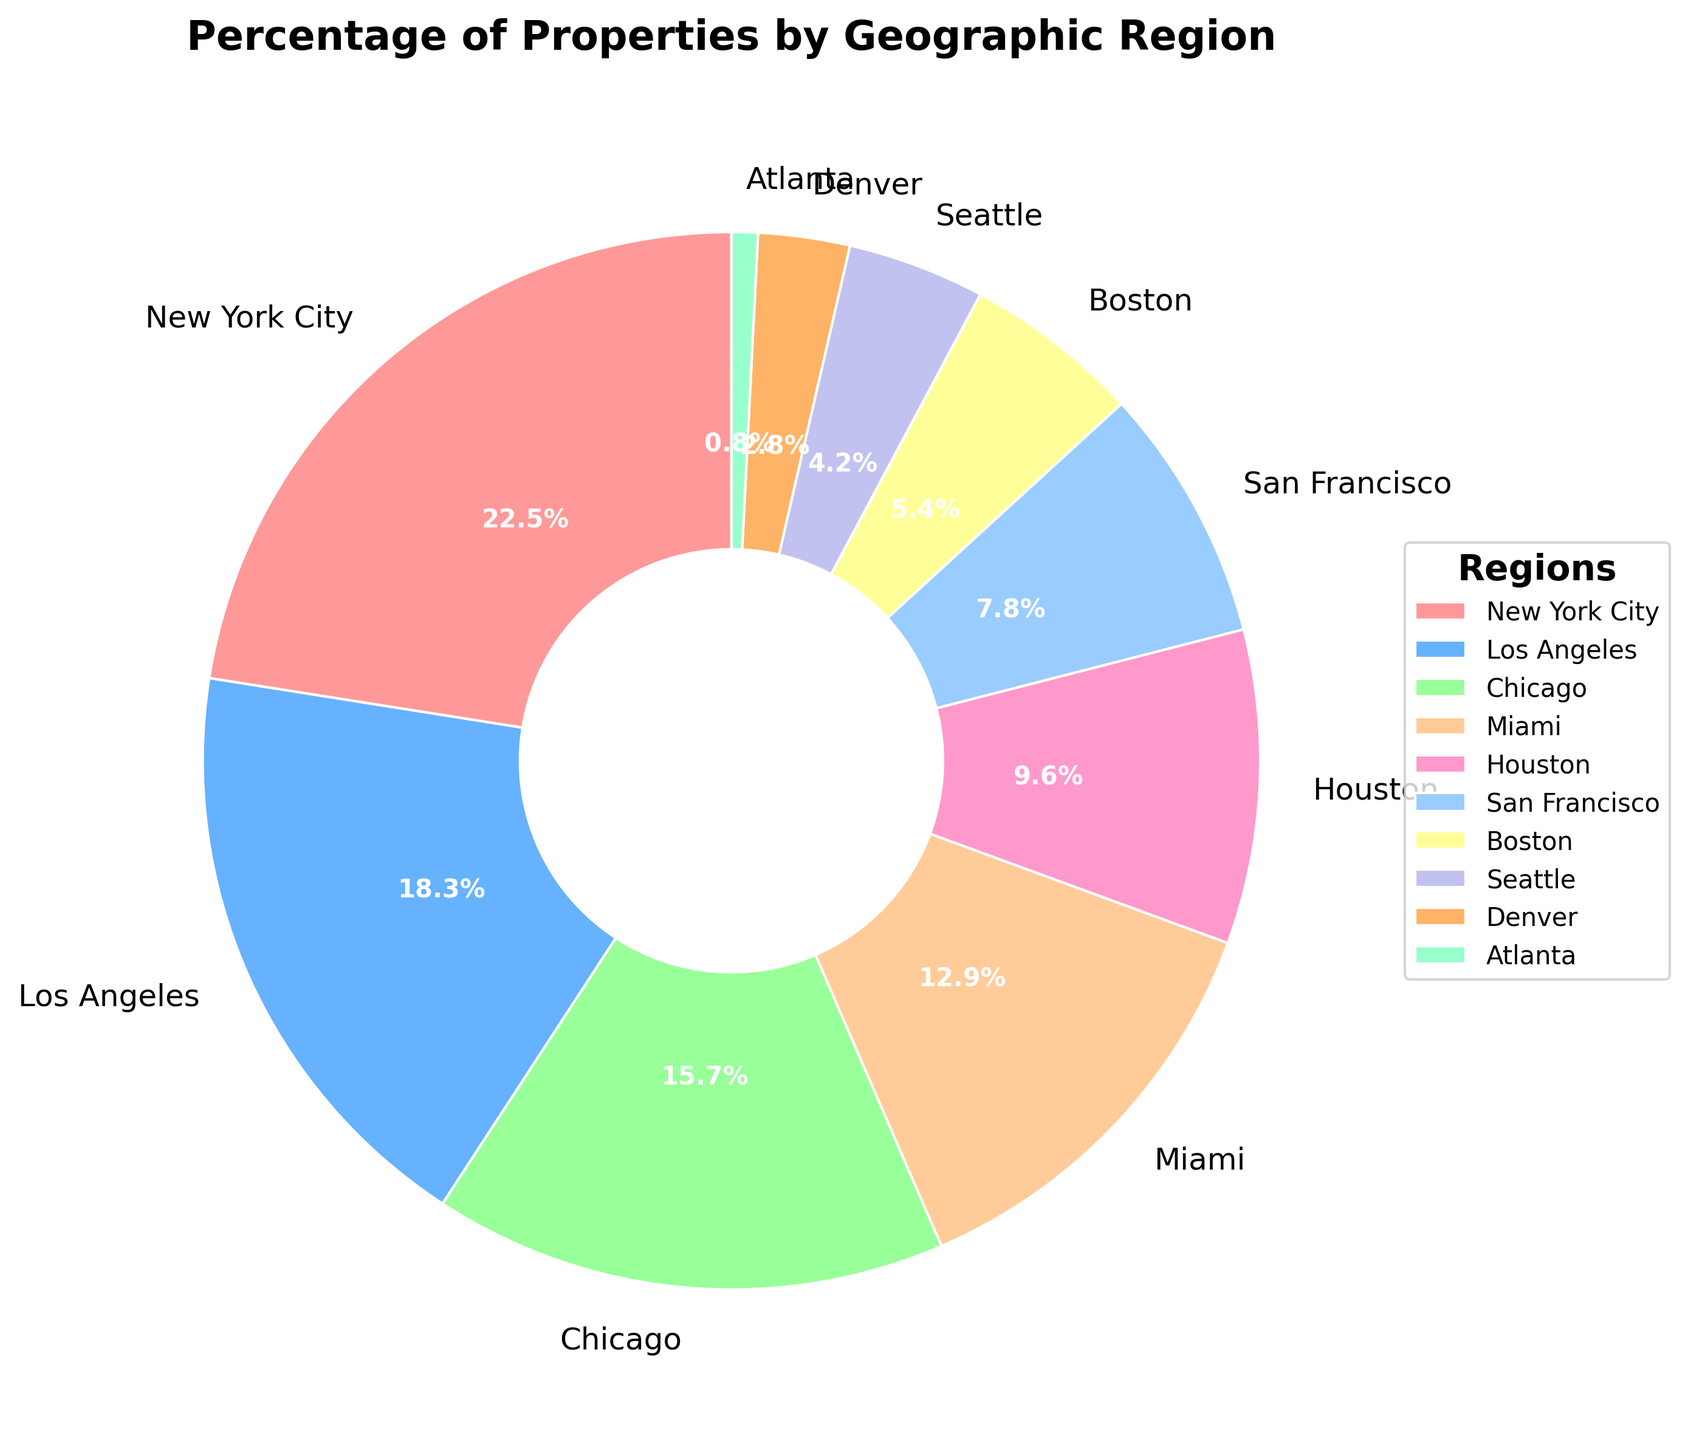Which region represents the largest percentage of properties? From the pie chart, observe which segment is the largest. The New York City region's segment is the largest with 22.5%.
Answer: New York City Which two regions combined have almost the same percentage as New York City? New York City's percentage is 22.5. Adding Los Angeles (18.3%) and Atlanta (0.8%) gives 19.1%. Adding Chicago (15.7%) and Seattle (4.2%) gives 19.9%. Adding San Francisco (7.8%) and Boston (5.4%) gives 13.2%. Adding Miami (12.9%) and Houston (9.6%) gives 22.5%, which matches New York City.
Answer: Miami and Houston How much greater is the percentage of properties in Chicago compared to Seattle? Chicago's percentage is 15.7% while Seattle's is 4.2%. Subtracting Seattle’s percentage from Chicago’s percentage (15.7 - 4.2) results in 11.5%.
Answer: 11.5% What is the total percentage of properties in regions San Francisco, Boston, and Seattle? Adding the percentages for San Francisco (7.8%), Boston (5.4%), and Seattle (4.2%) gives the total percentage (7.8 + 5.4 + 4.2 = 17.4%).
Answer: 17.4% Which region represents the smallest percentage of properties? From the pie chart, observe which segment is the smallest. The Atlanta region's segment is the smallest with 0.8%.
Answer: Atlanta Is the percentage of properties in Los Angeles more than double that of Miami? Los Angeles has 18.3% and Miami has 12.9%. Doubling Miami’s percentage results in 12.9 * 2 = 25.8%. Since 18.3% is less than 25.8%, Los Angeles has less than double Miami’s percentage.
Answer: No Compare the percentages of properties in New York City and Chicago. Which is larger and by how much? New York City's percentage is 22.5%, whereas Chicago's is 15.7%. New York City's percentage is 22.5 - 15.7 = 6.8% larger than Chicago’s.
Answer: New York City, 6.8% How many regions have a percentage of properties greater than 10%? Counting the segments with percentages greater than 10%: New York City (22.5%), Los Angeles (18.3%), Chicago (15.7%), and Miami (12.9%). There are four regions.
Answer: 4 If you combine the percentages of properties in Boston and San Francisco, is the total more than or less than Houston's percentage? Boston has 5.4% and San Francisco has 7.8%. Adding these gives 5.4 + 7.8 = 13.2%, which is more than Houston’s percentage of 9.6%.
Answer: More 